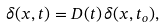<formula> <loc_0><loc_0><loc_500><loc_500>\delta ( { x } , t ) = D ( t ) \, \delta ( { x } , t _ { o } ) ,</formula> 